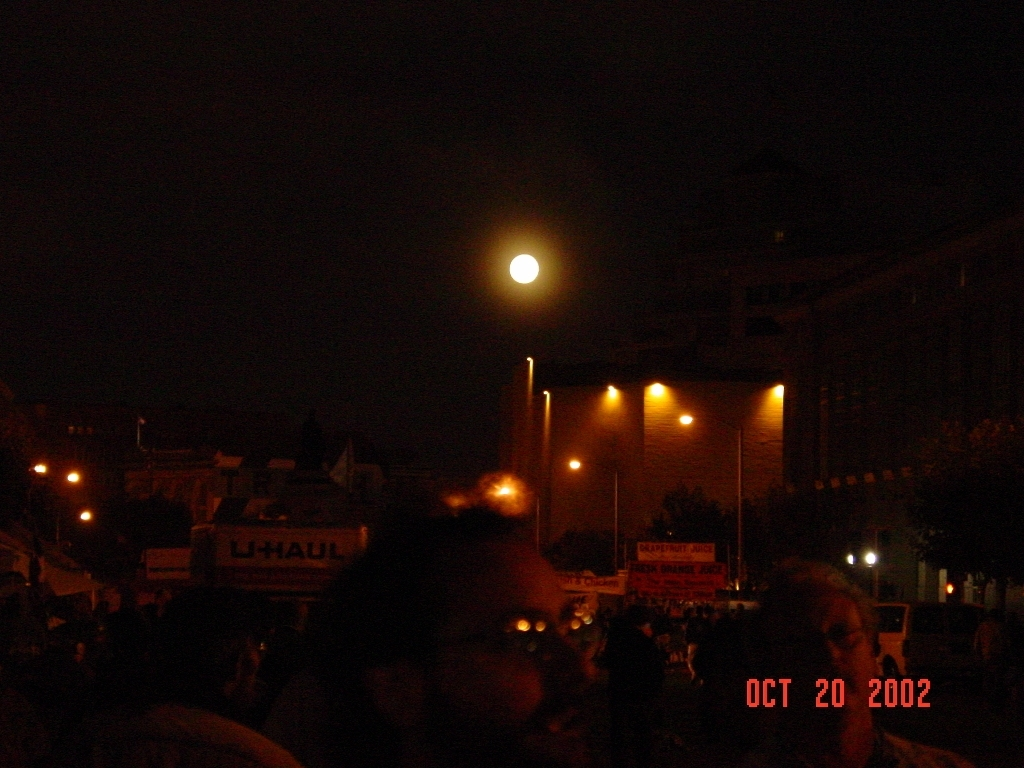Provide insights on how the date in the image influences its historical context. The date marked on the image is 'OCT 20 2002'. This places the photograph in the early 21st century, a period not too distant in the past yet far enough to indicate significant differences in style, technology, and possibly the type of event being captured, when compared to current standards. 